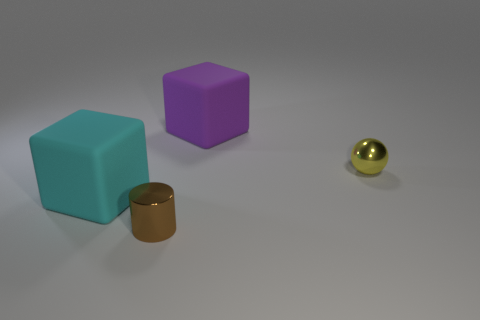There is another thing that is the same shape as the big purple object; what is its color?
Your response must be concise. Cyan. There is another rubber thing that is the same shape as the large purple matte thing; what is its size?
Ensure brevity in your answer.  Large. There is a cube to the right of the big cyan matte cube; what is it made of?
Keep it short and to the point. Rubber. Is the number of small yellow metallic objects that are behind the small brown metal object less than the number of small green cubes?
Your response must be concise. No. What is the shape of the rubber object to the right of the matte block left of the purple block?
Keep it short and to the point. Cube. What color is the small shiny sphere?
Give a very brief answer. Yellow. What number of other things are the same size as the yellow thing?
Offer a terse response. 1. There is a object that is both to the left of the purple thing and behind the brown shiny cylinder; what material is it made of?
Give a very brief answer. Rubber. There is a block in front of the ball; is it the same size as the ball?
Offer a very short reply. No. Do the metal ball and the metallic cylinder have the same color?
Keep it short and to the point. No. 